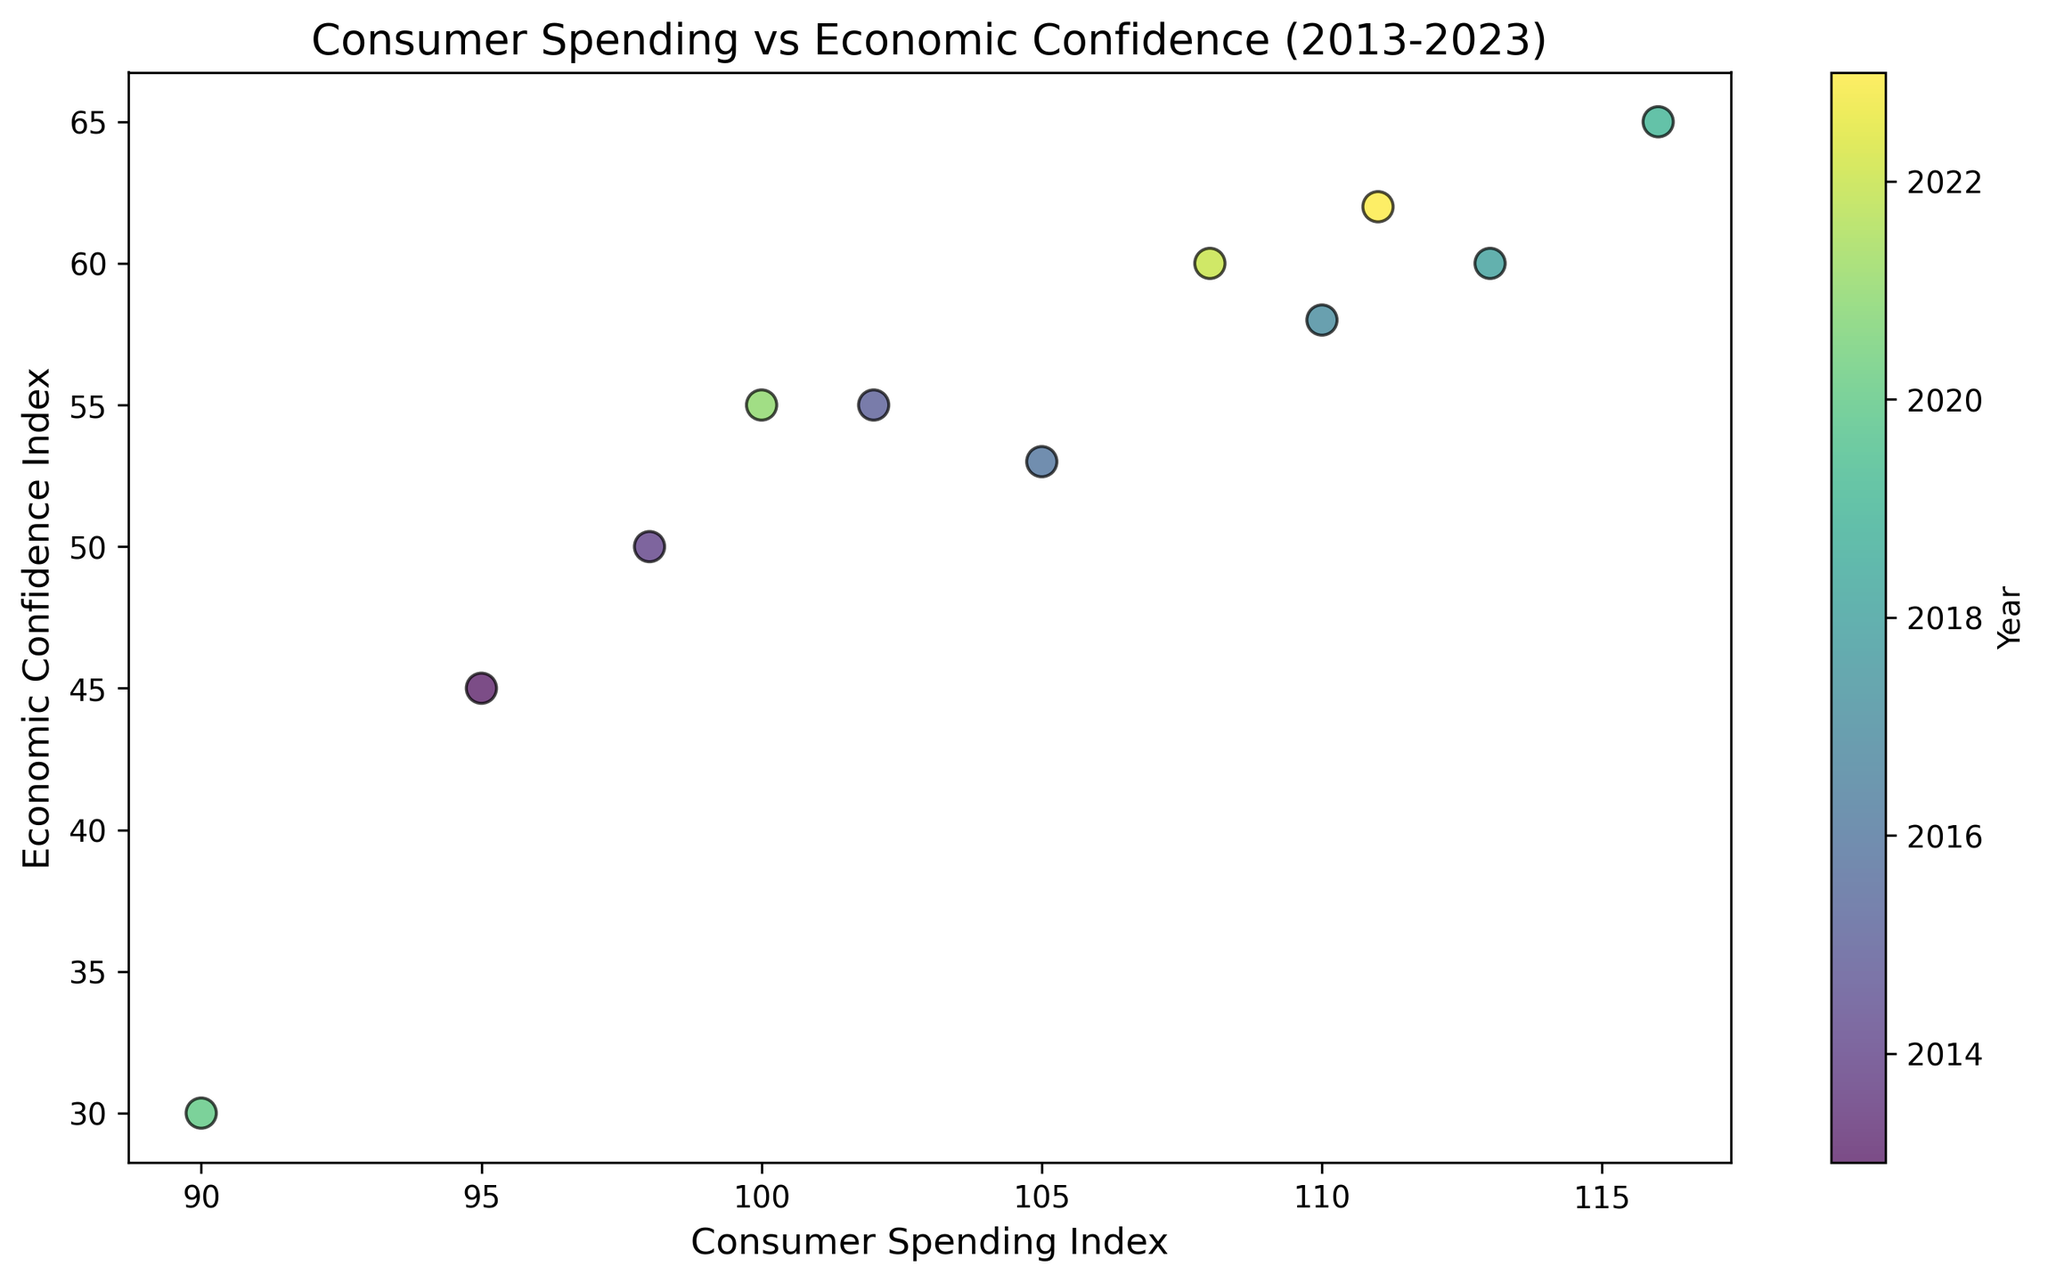What trend can you observe between the Consumer Spending Index and the Economic Confidence Index from 2013 to 2023? The scatter plot generally shows a positive correlation between Consumer Spending Index and Economic Confidence Index, implying that as economic confidence increases, consumer spending also tends to increase.
Answer: Positive correlation In which year did the Consumer Spending Index see the largest drop, and what was the corresponding Economic Confidence Index? The largest drop in the Consumer Spending Index occurred in 2020, where the index dropped to 90. The corresponding Economic Confidence Index for that year was 30.
Answer: 2020, 30 What is the difference between the Consumer Spending Index and Economic Confidence Index in 2013? In 2013, the Consumer Spending Index is 95 and the Economic Confidence Index is 45. The difference is 95 - 45 = 50.
Answer: 50 Which year had the highest Economic Confidence Index, and what was the Consumer Spending Index for that year? The highest Economic Confidence Index was in 2019, with a value of 65. The corresponding Consumer Spending Index for that year was 116.
Answer: 2019, 116 Which data point on the scatter plot represents a year with both the highest Consumer Spending Index and Economic Confidence Index? The data point representing the year 2019 shows both the highest Consumer Spending Index (116) and the highest Economic Confidence Index (65).
Answer: 2019 In which years did the Consumer Spending Index exceed 110, and what were their respective Economic Confidence Indices? The Consumer Spending Index exceeded 110 in the years 2018 (113), 2019 (116), 2022 (108), and 2023 (111). Their respective Economic Confidence Indices were 60 (2018), 65 (2019), 60 (2022), and 62 (2023).
Answer: 2018: 60, 2019: 65, 2022: 60, 2023: 62 How did the Economic Confidence Index change from 2019 to 2020, and what can you infer about consumer spending in these years? The Economic Confidence Index dropped from 65 in 2019 to 30 in 2020. Correspondingly, the Consumer Spending Index also significantly dropped from 116 in 2019 to 90 in 2020, indicating a strong relationship between economic confidence and consumer spending.
Answer: Economic Confidence Index dropped by 35, and consumer spending dropped What is the average Economic Confidence Index for the years 2013, 2015, and 2017? The Economic Confidence Indices for the years 2013, 2015, and 2017 are 45, 55, and 58, respectively. The average is (45 + 55 + 58) / 3 = 52.67.
Answer: 52.67 Which year corresponds to the lightest color in the scatter plot, and what are the respective indices for that year? In the scatter plot, the lightest color correlates with the earliest year, 2013. For this year, the Consumer Spending Index is 95, and the Economic Confidence Index is 45.
Answer: 2013, 95, 45 Comparing 2016 and 2021, which year had a higher Consumer Spending Index, and by how much? The Consumer Spending Index in 2016 was 105, while in 2021 it was 100. The index in 2016 was higher by 105 - 100 = 5 units.
Answer: 2016, 5 